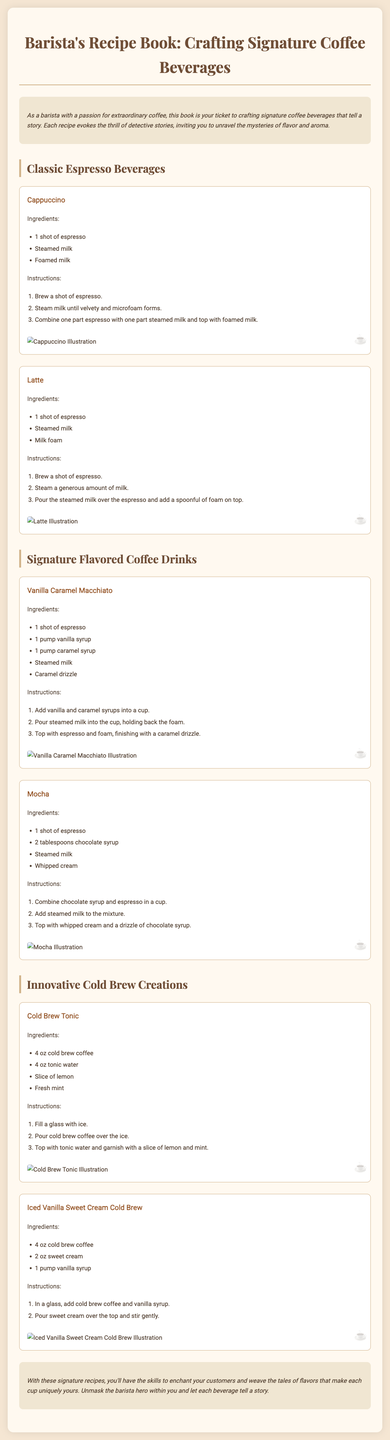what is the title of the document? The title of the document, as stated at the top, is "Barista's Recipe Book: Crafting Signature Coffee Beverages."
Answer: Barista's Recipe Book: Crafting Signature Coffee Beverages how many shots of espresso are used in a latte? The recipe for a latte specifies the use of one shot of espresso.
Answer: 1 shot what is the main ingredient in a cold brew tonic? The main ingredient listed for a cold brew tonic is cold brew coffee.
Answer: cold brew coffee what decorative item is used on top of the mocha? The mocha recipe calls for a topping of whipped cream.
Answer: whipped cream how many recipes are included in the section for classic espresso beverages? There are two recipes included in the classic espresso beverages section: Cappuccino and Latte.
Answer: 2 what flavor syrups are used in the Vanilla Caramel Macchiato? The Vanilla Caramel Macchiato uses vanilla syrup and caramel syrup.
Answer: vanilla syrup and caramel syrup what is the total number of ingredients needed for the Iced Vanilla Sweet Cream Cold Brew? The Iced Vanilla Sweet Cream Cold Brew requires three ingredients: cold brew coffee, sweet cream, and vanilla syrup.
Answer: 3 which ingredient is not used in a cappuccino? Foamed milk is not mentioned as a distinct ingredient; only steamed milk and foamed milk are used in combination.
Answer: foamed milk what type of beverage is the Cold Brew Tonic? The Cold Brew Tonic falls under the category of innovative cold brew creations.
Answer: innovative cold brew creations 